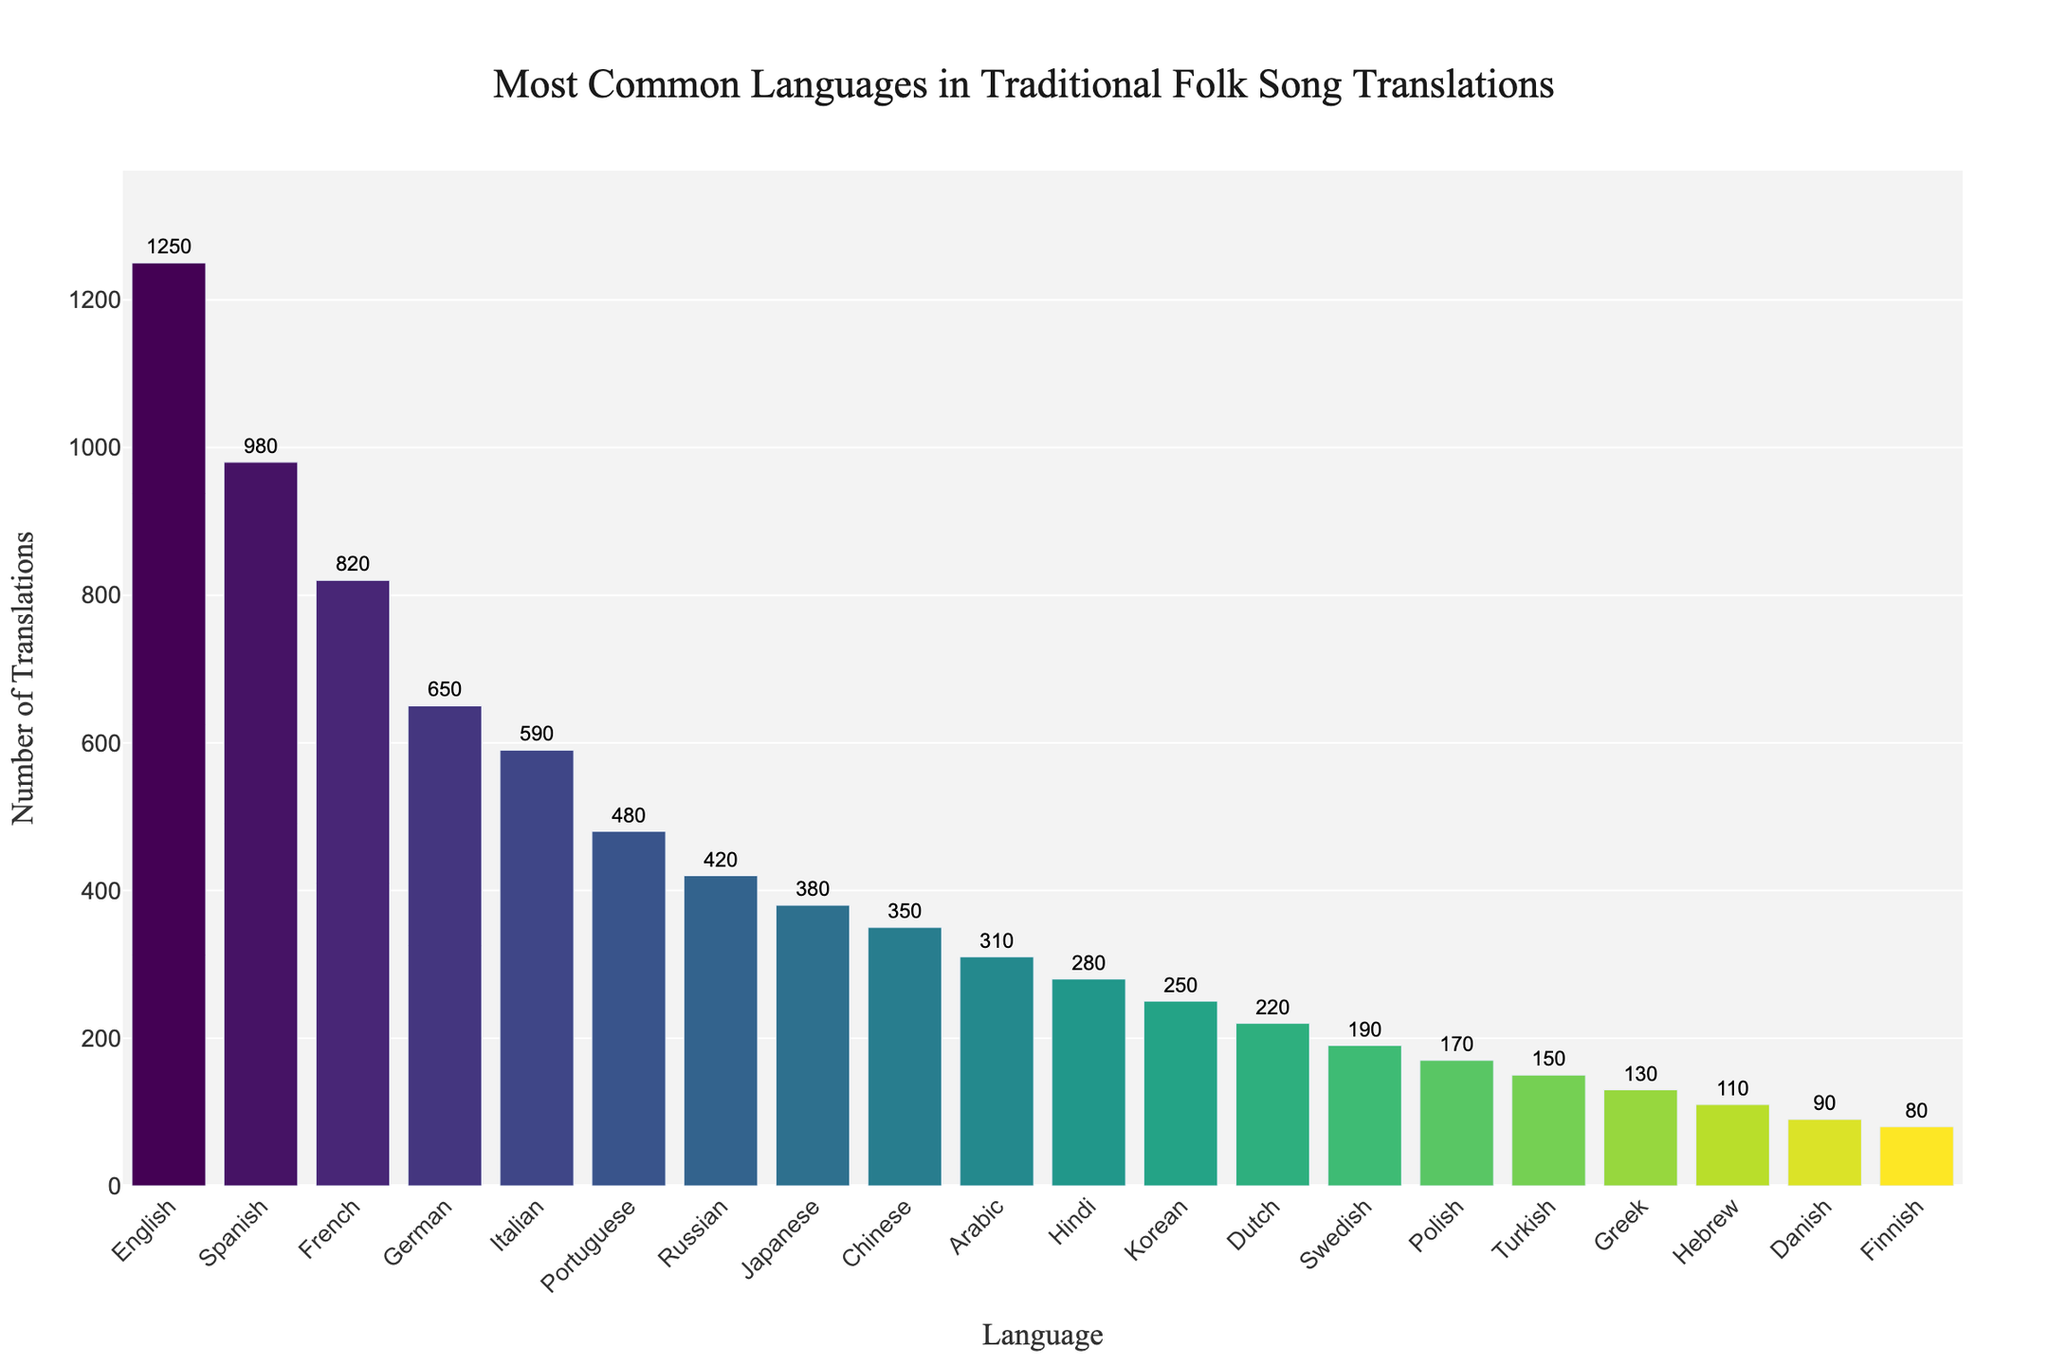Which language has the highest number of translations? The bar chart shows the languages along the x-axis and the number of translations along the y-axis. The highest bar represents the language with the most translations. English has the highest bar.
Answer: English Which two languages have the least number of translations? To identify the least translated languages, look at the two shortest bars on the chart. They are Danish and Finnish.
Answer: Danish and Finnish How many total translations are there for the top three languages? To find the total, first identify the top three languages: English (1250), Spanish (980), and French (820). Sum these values: 1250 + 980 + 820.
Answer: 3050 Which language has 250 translations? Find the bar labeled with a value of 250 translations. The corresponding language is Korean.
Answer: Korean How many more translations does Spanish have compared to Japanese? Find the number of translations for Spanish (980) and Japanese (380). Subtract the smaller value from the larger one: 980 - 380.
Answer: 600 What is the combined number of translations for Arabic and Hebrew? Identify the number of translations for Arabic (310) and Hebrew (110). Sum these values: 310 + 110.
Answer: 420 Are there more translations in Italian or Portuguese folk songs? Compare the heights of the bars for Italian (590) and Portuguese (480). The height for Italian is greater.
Answer: Italian Which language is translated into 420 versions? Refer to the hover text or the bars to locate the language with 420 translations. The language is Russian.
Answer: Russian How many more translations does French have than German? Find the values for French (820) and German (650). Calculate the difference: 820 - 650.
Answer: 170 